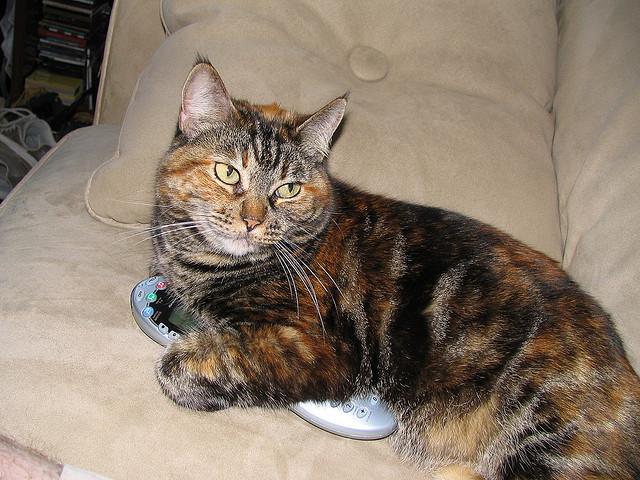Is the cat protecting the remote control?
Be succinct. Yes. Is the cat asleep or awake?
Write a very short answer. Awake. What color is the power button?
Be succinct. Red. Was the cat asleep or ready to pounce?
Short answer required. Asleep. 